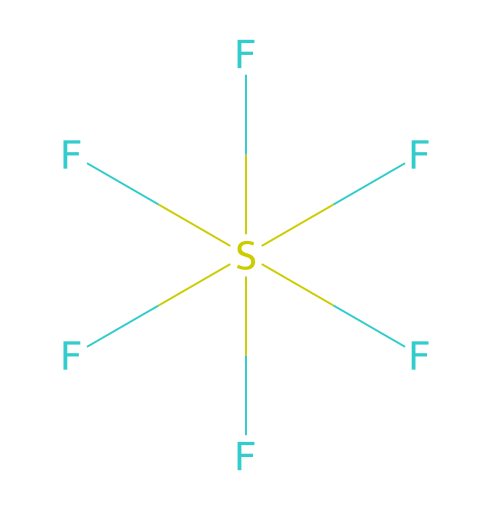How many sulfur atoms are in sulfur hexafluoride? The SMILES representation shows a single sulfur atom denoted by 'S' in the center of the structure. Therefore, there is only one sulfur atom present.
Answer: 1 How many fluorine atoms are present in sulfur hexafluoride? The SMILES representation indicates multiple fluorine atoms attached to the sulfur atom, specifically six instances of 'F', indicating there are six fluorine atoms present.
Answer: 6 What is the hybridization of the sulfur atom in sulfur hexafluoride? The sulfur atom is surrounded by six fluorine atoms, requiring sp³d² hybridization to accommodate the six pairs of electrons (bonds) formed with fluorine.
Answer: sp³d² Is sulfur hexafluoride a hypervalent compound? Hypervalent compounds are characterized by a central atom that can accommodate more than four bonds. In this case, sulfur has six bonds to fluorine, qualifying it as hypervalent.
Answer: yes What molecular geometry does sulfur hexafluoride exhibit? The presence of six surrounding fluorine atoms indicates that the molecular geometry is octahedral, which arises from the symmetrical arrangement of six equivalent bonds.
Answer: octahedral How many valence electrons does sulfur contribute to sulfur hexafluoride? Sulfur belongs to group 16 and has six valence electrons. In this configuration, it utilizes all of them to form bonds with fluorine atoms.
Answer: 6 Does sulfur hexafluoride have a lone pair of electrons on the sulfur atom? Given that all six valence electrons of sulfur are used to form bonds with fluorine atoms, there are no remaining lone pairs on the sulfur atom in this molecule.
Answer: no 